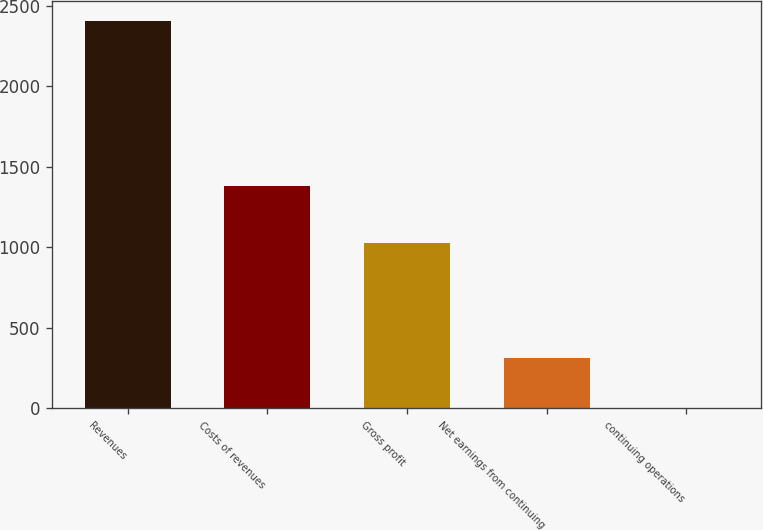Convert chart. <chart><loc_0><loc_0><loc_500><loc_500><bar_chart><fcel>Revenues<fcel>Costs of revenues<fcel>Gross profit<fcel>Net earnings from continuing<fcel>continuing operations<nl><fcel>2405.7<fcel>1380.3<fcel>1025.4<fcel>310.1<fcel>0.63<nl></chart> 